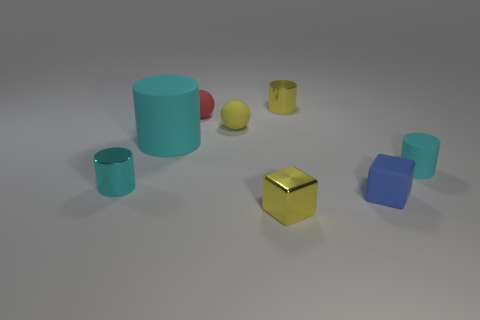Subtract all gray blocks. How many cyan cylinders are left? 3 Add 1 large cyan cylinders. How many objects exist? 9 Subtract all cubes. How many objects are left? 6 Subtract all yellow metal objects. Subtract all tiny yellow matte balls. How many objects are left? 5 Add 8 blue blocks. How many blue blocks are left? 9 Add 7 cyan rubber cylinders. How many cyan rubber cylinders exist? 9 Subtract 0 green spheres. How many objects are left? 8 